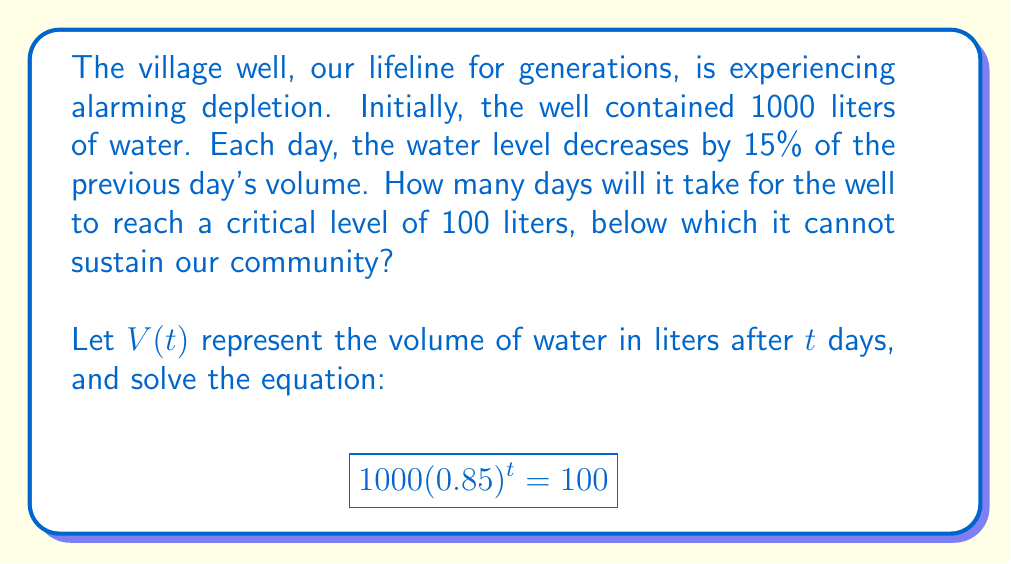Could you help me with this problem? Let's approach this step-by-step:

1) We start with the exponential function for the water volume:
   $V(t) = 1000(0.85)^t$

2) We want to find when this equals 100 liters:
   $1000(0.85)^t = 100$

3) Divide both sides by 1000:
   $(0.85)^t = 0.1$

4) Take the natural logarithm of both sides:
   $t \ln(0.85) = \ln(0.1)$

5) Solve for $t$:
   $t = \frac{\ln(0.1)}{\ln(0.85)}$

6) Calculate this value:
   $t \approx 13.357$

7) Since we can only have whole days, we round up to the next integer:
   $t = 14$ days

Therefore, it will take 14 days for the well to reach the critical level of 100 liters.
Answer: 14 days 